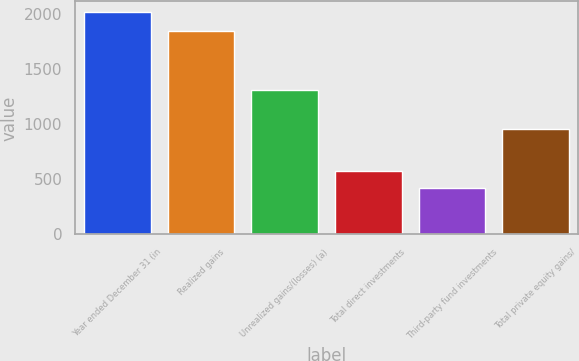Convert chart. <chart><loc_0><loc_0><loc_500><loc_500><bar_chart><fcel>Year ended December 31 (in<fcel>Realized gains<fcel>Unrealized gains/(losses) (a)<fcel>Total direct investments<fcel>Third-party fund investments<fcel>Total private equity gains/<nl><fcel>2011<fcel>1842<fcel>1305<fcel>576.4<fcel>417<fcel>954<nl></chart> 